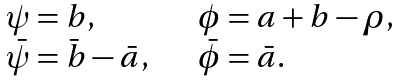Convert formula to latex. <formula><loc_0><loc_0><loc_500><loc_500>\begin{array} { l l } \psi = b , & \phi = a + b - \rho , \\ \bar { \psi } = \bar { b } - \bar { a } , \quad & \bar { \phi } = \bar { a } . \end{array}</formula> 